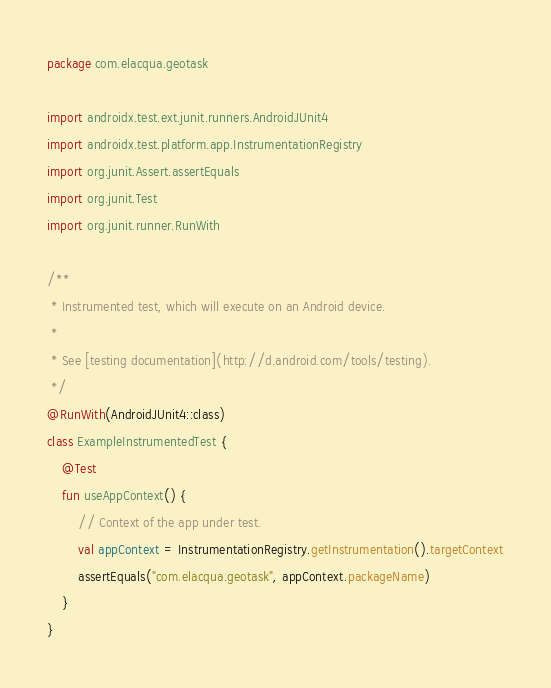<code> <loc_0><loc_0><loc_500><loc_500><_Kotlin_>package com.elacqua.geotask

import androidx.test.ext.junit.runners.AndroidJUnit4
import androidx.test.platform.app.InstrumentationRegistry
import org.junit.Assert.assertEquals
import org.junit.Test
import org.junit.runner.RunWith

/**
 * Instrumented test, which will execute on an Android device.
 *
 * See [testing documentation](http://d.android.com/tools/testing).
 */
@RunWith(AndroidJUnit4::class)
class ExampleInstrumentedTest {
    @Test
    fun useAppContext() {
        // Context of the app under test.
        val appContext = InstrumentationRegistry.getInstrumentation().targetContext
        assertEquals("com.elacqua.geotask", appContext.packageName)
    }
}</code> 